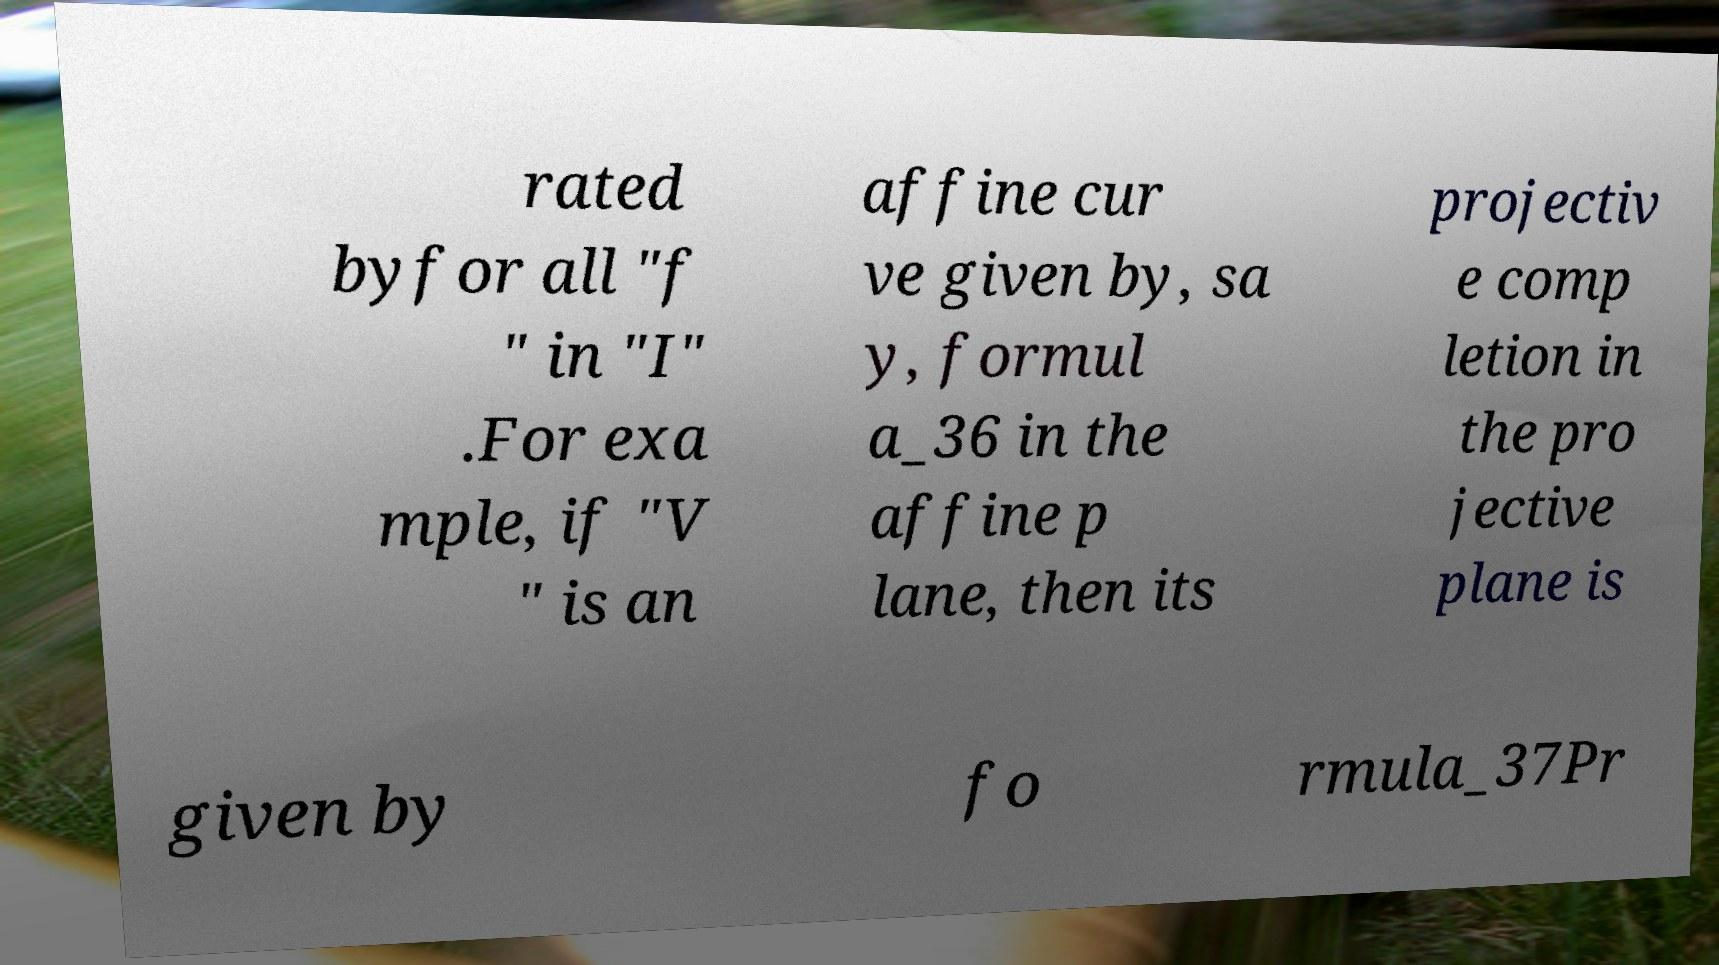Can you accurately transcribe the text from the provided image for me? rated byfor all "f " in "I" .For exa mple, if "V " is an affine cur ve given by, sa y, formul a_36 in the affine p lane, then its projectiv e comp letion in the pro jective plane is given by fo rmula_37Pr 